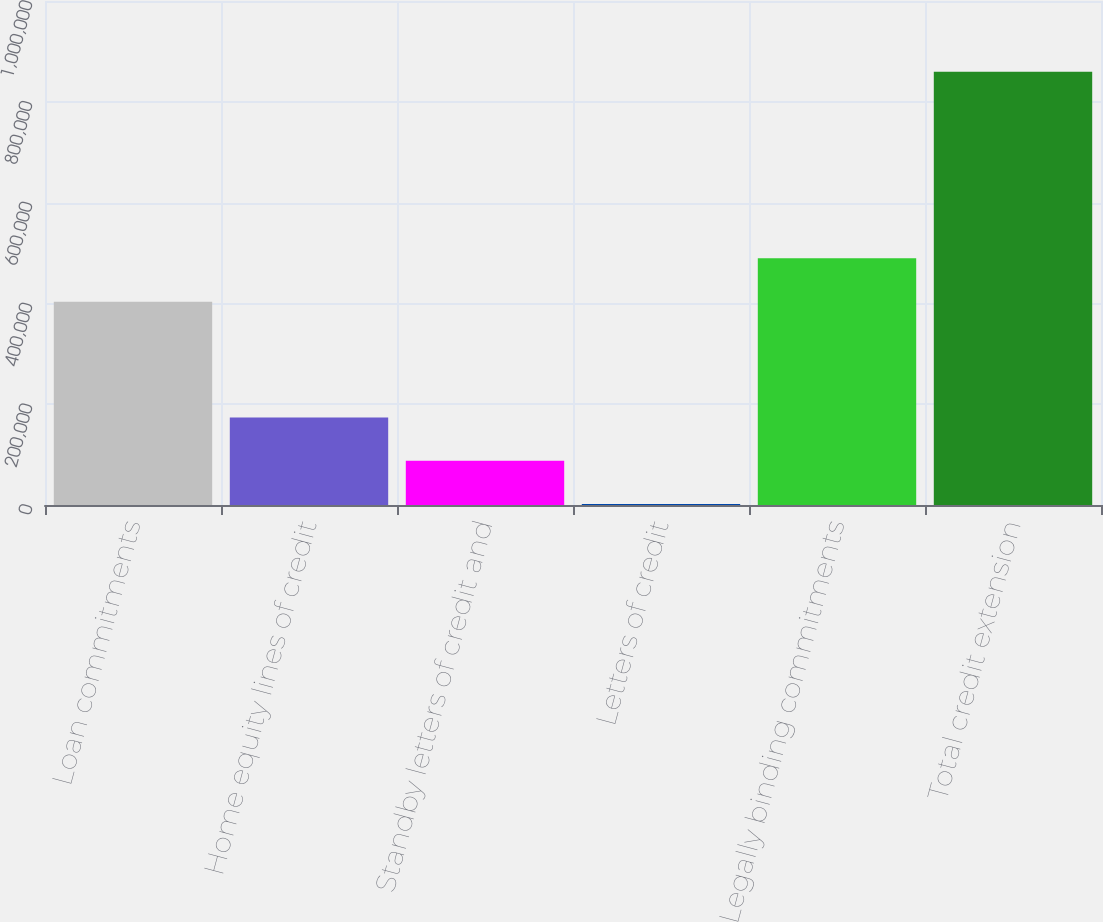<chart> <loc_0><loc_0><loc_500><loc_500><bar_chart><fcel>Loan commitments<fcel>Home equity lines of credit<fcel>Standby letters of credit and<fcel>Letters of credit<fcel>Legally binding commitments<fcel>Total credit extension<nl><fcel>403177<fcel>173673<fcel>87899.9<fcel>2127<fcel>489729<fcel>859856<nl></chart> 